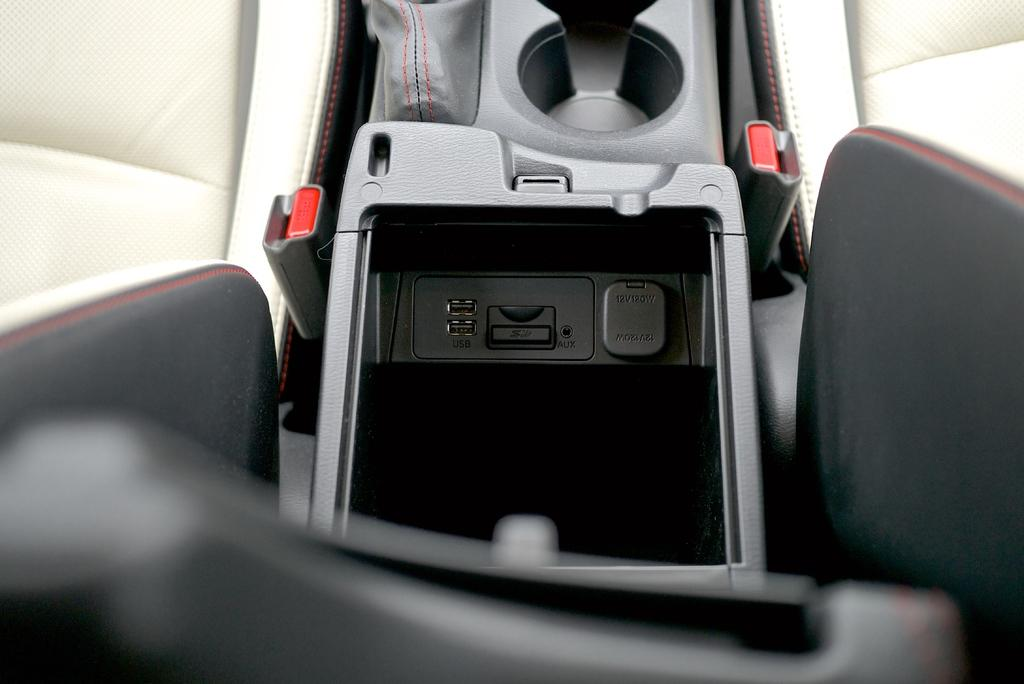What is the setting of the image? The image is of the inside of a car. How many seats are visible in the car? There are two seats in the car. What feature is located between the seats? There is a cup holder between the seats. What is another feature located between the seats? There is a seat belt holder between the seats. What additional feature can be seen between the seats? There is a tray between the seats. What type of vase is present on the tray between the seats? There is no vase present on the tray between the seats in the image. 